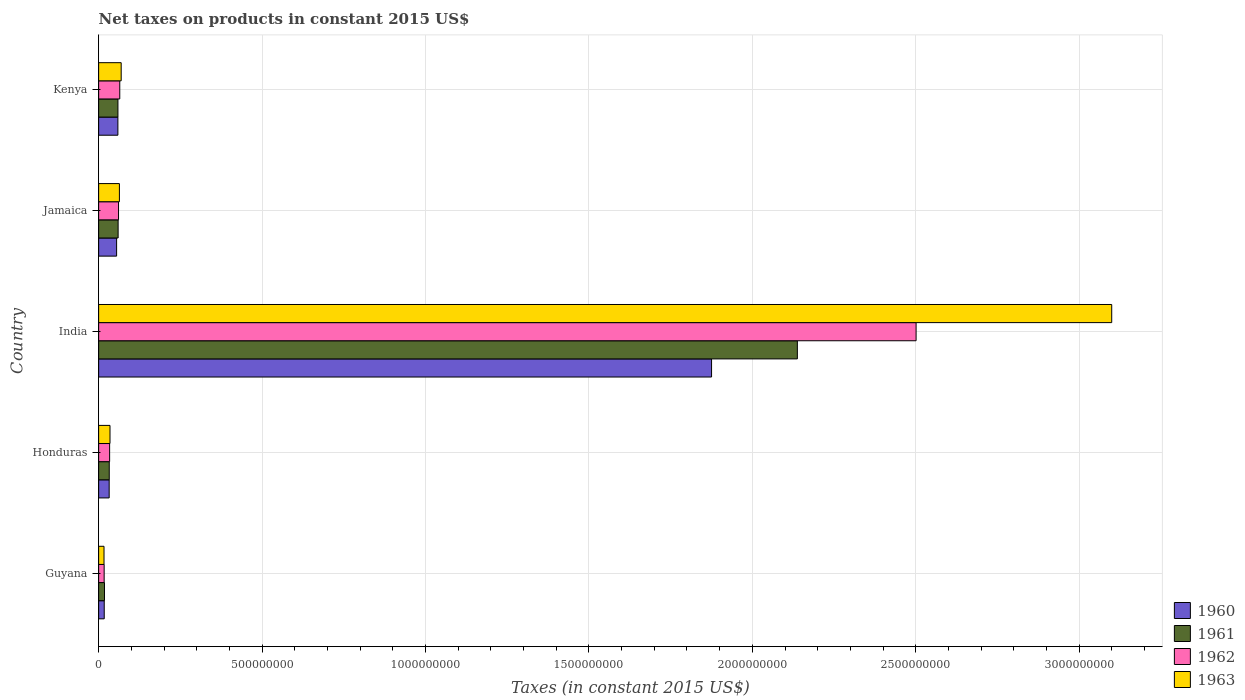How many different coloured bars are there?
Make the answer very short. 4. How many groups of bars are there?
Make the answer very short. 5. Are the number of bars on each tick of the Y-axis equal?
Offer a very short reply. Yes. How many bars are there on the 2nd tick from the top?
Provide a short and direct response. 4. How many bars are there on the 1st tick from the bottom?
Your response must be concise. 4. What is the label of the 2nd group of bars from the top?
Your answer should be very brief. Jamaica. In how many cases, is the number of bars for a given country not equal to the number of legend labels?
Offer a terse response. 0. What is the net taxes on products in 1962 in Guyana?
Your answer should be compact. 1.69e+07. Across all countries, what is the maximum net taxes on products in 1962?
Your answer should be very brief. 2.50e+09. Across all countries, what is the minimum net taxes on products in 1962?
Keep it short and to the point. 1.69e+07. In which country was the net taxes on products in 1960 minimum?
Ensure brevity in your answer.  Guyana. What is the total net taxes on products in 1961 in the graph?
Provide a succinct answer. 2.31e+09. What is the difference between the net taxes on products in 1961 in Guyana and that in Honduras?
Offer a very short reply. -1.46e+07. What is the difference between the net taxes on products in 1961 in Guyana and the net taxes on products in 1962 in Kenya?
Ensure brevity in your answer.  -4.67e+07. What is the average net taxes on products in 1963 per country?
Offer a terse response. 6.57e+08. What is the difference between the net taxes on products in 1962 and net taxes on products in 1960 in India?
Your answer should be compact. 6.26e+08. In how many countries, is the net taxes on products in 1963 greater than 2000000000 US$?
Provide a succinct answer. 1. What is the ratio of the net taxes on products in 1962 in Guyana to that in Honduras?
Give a very brief answer. 0.5. Is the net taxes on products in 1961 in Jamaica less than that in Kenya?
Provide a succinct answer. No. What is the difference between the highest and the second highest net taxes on products in 1960?
Ensure brevity in your answer.  1.82e+09. What is the difference between the highest and the lowest net taxes on products in 1960?
Give a very brief answer. 1.86e+09. In how many countries, is the net taxes on products in 1963 greater than the average net taxes on products in 1963 taken over all countries?
Offer a very short reply. 1. Is the sum of the net taxes on products in 1962 in Guyana and Honduras greater than the maximum net taxes on products in 1960 across all countries?
Offer a very short reply. No. Is it the case that in every country, the sum of the net taxes on products in 1962 and net taxes on products in 1963 is greater than the sum of net taxes on products in 1961 and net taxes on products in 1960?
Ensure brevity in your answer.  No. What does the 4th bar from the top in Honduras represents?
Your answer should be compact. 1960. What does the 4th bar from the bottom in Jamaica represents?
Provide a succinct answer. 1963. Is it the case that in every country, the sum of the net taxes on products in 1962 and net taxes on products in 1961 is greater than the net taxes on products in 1960?
Provide a short and direct response. Yes. How many bars are there?
Offer a very short reply. 20. How many countries are there in the graph?
Keep it short and to the point. 5. Are the values on the major ticks of X-axis written in scientific E-notation?
Offer a very short reply. No. Where does the legend appear in the graph?
Ensure brevity in your answer.  Bottom right. How many legend labels are there?
Make the answer very short. 4. How are the legend labels stacked?
Your answer should be very brief. Vertical. What is the title of the graph?
Make the answer very short. Net taxes on products in constant 2015 US$. What is the label or title of the X-axis?
Offer a very short reply. Taxes (in constant 2015 US$). What is the Taxes (in constant 2015 US$) of 1960 in Guyana?
Give a very brief answer. 1.71e+07. What is the Taxes (in constant 2015 US$) in 1961 in Guyana?
Your answer should be very brief. 1.79e+07. What is the Taxes (in constant 2015 US$) in 1962 in Guyana?
Offer a very short reply. 1.69e+07. What is the Taxes (in constant 2015 US$) of 1963 in Guyana?
Ensure brevity in your answer.  1.64e+07. What is the Taxes (in constant 2015 US$) in 1960 in Honduras?
Give a very brief answer. 3.22e+07. What is the Taxes (in constant 2015 US$) of 1961 in Honduras?
Provide a succinct answer. 3.25e+07. What is the Taxes (in constant 2015 US$) of 1962 in Honduras?
Ensure brevity in your answer.  3.36e+07. What is the Taxes (in constant 2015 US$) of 1963 in Honduras?
Provide a short and direct response. 3.48e+07. What is the Taxes (in constant 2015 US$) in 1960 in India?
Make the answer very short. 1.88e+09. What is the Taxes (in constant 2015 US$) of 1961 in India?
Offer a very short reply. 2.14e+09. What is the Taxes (in constant 2015 US$) of 1962 in India?
Offer a very short reply. 2.50e+09. What is the Taxes (in constant 2015 US$) in 1963 in India?
Provide a short and direct response. 3.10e+09. What is the Taxes (in constant 2015 US$) of 1960 in Jamaica?
Provide a succinct answer. 5.50e+07. What is the Taxes (in constant 2015 US$) of 1961 in Jamaica?
Make the answer very short. 5.96e+07. What is the Taxes (in constant 2015 US$) in 1962 in Jamaica?
Make the answer very short. 6.09e+07. What is the Taxes (in constant 2015 US$) in 1963 in Jamaica?
Your answer should be very brief. 6.36e+07. What is the Taxes (in constant 2015 US$) of 1960 in Kenya?
Your response must be concise. 5.89e+07. What is the Taxes (in constant 2015 US$) of 1961 in Kenya?
Make the answer very short. 5.91e+07. What is the Taxes (in constant 2015 US$) of 1962 in Kenya?
Your answer should be very brief. 6.47e+07. What is the Taxes (in constant 2015 US$) of 1963 in Kenya?
Your response must be concise. 6.90e+07. Across all countries, what is the maximum Taxes (in constant 2015 US$) in 1960?
Provide a succinct answer. 1.88e+09. Across all countries, what is the maximum Taxes (in constant 2015 US$) in 1961?
Provide a short and direct response. 2.14e+09. Across all countries, what is the maximum Taxes (in constant 2015 US$) of 1962?
Provide a short and direct response. 2.50e+09. Across all countries, what is the maximum Taxes (in constant 2015 US$) of 1963?
Your response must be concise. 3.10e+09. Across all countries, what is the minimum Taxes (in constant 2015 US$) in 1960?
Provide a short and direct response. 1.71e+07. Across all countries, what is the minimum Taxes (in constant 2015 US$) in 1961?
Your answer should be very brief. 1.79e+07. Across all countries, what is the minimum Taxes (in constant 2015 US$) in 1962?
Offer a very short reply. 1.69e+07. Across all countries, what is the minimum Taxes (in constant 2015 US$) in 1963?
Make the answer very short. 1.64e+07. What is the total Taxes (in constant 2015 US$) in 1960 in the graph?
Your response must be concise. 2.04e+09. What is the total Taxes (in constant 2015 US$) of 1961 in the graph?
Your answer should be compact. 2.31e+09. What is the total Taxes (in constant 2015 US$) in 1962 in the graph?
Keep it short and to the point. 2.68e+09. What is the total Taxes (in constant 2015 US$) of 1963 in the graph?
Your answer should be very brief. 3.28e+09. What is the difference between the Taxes (in constant 2015 US$) of 1960 in Guyana and that in Honduras?
Offer a very short reply. -1.51e+07. What is the difference between the Taxes (in constant 2015 US$) in 1961 in Guyana and that in Honduras?
Provide a short and direct response. -1.46e+07. What is the difference between the Taxes (in constant 2015 US$) of 1962 in Guyana and that in Honduras?
Keep it short and to the point. -1.67e+07. What is the difference between the Taxes (in constant 2015 US$) in 1963 in Guyana and that in Honduras?
Give a very brief answer. -1.84e+07. What is the difference between the Taxes (in constant 2015 US$) in 1960 in Guyana and that in India?
Give a very brief answer. -1.86e+09. What is the difference between the Taxes (in constant 2015 US$) of 1961 in Guyana and that in India?
Offer a very short reply. -2.12e+09. What is the difference between the Taxes (in constant 2015 US$) in 1962 in Guyana and that in India?
Your response must be concise. -2.48e+09. What is the difference between the Taxes (in constant 2015 US$) of 1963 in Guyana and that in India?
Offer a terse response. -3.08e+09. What is the difference between the Taxes (in constant 2015 US$) in 1960 in Guyana and that in Jamaica?
Your response must be concise. -3.79e+07. What is the difference between the Taxes (in constant 2015 US$) of 1961 in Guyana and that in Jamaica?
Your response must be concise. -4.17e+07. What is the difference between the Taxes (in constant 2015 US$) of 1962 in Guyana and that in Jamaica?
Offer a very short reply. -4.40e+07. What is the difference between the Taxes (in constant 2015 US$) in 1963 in Guyana and that in Jamaica?
Ensure brevity in your answer.  -4.71e+07. What is the difference between the Taxes (in constant 2015 US$) of 1960 in Guyana and that in Kenya?
Keep it short and to the point. -4.18e+07. What is the difference between the Taxes (in constant 2015 US$) of 1961 in Guyana and that in Kenya?
Offer a terse response. -4.12e+07. What is the difference between the Taxes (in constant 2015 US$) in 1962 in Guyana and that in Kenya?
Keep it short and to the point. -4.77e+07. What is the difference between the Taxes (in constant 2015 US$) in 1963 in Guyana and that in Kenya?
Give a very brief answer. -5.26e+07. What is the difference between the Taxes (in constant 2015 US$) of 1960 in Honduras and that in India?
Keep it short and to the point. -1.84e+09. What is the difference between the Taxes (in constant 2015 US$) of 1961 in Honduras and that in India?
Your answer should be compact. -2.11e+09. What is the difference between the Taxes (in constant 2015 US$) in 1962 in Honduras and that in India?
Give a very brief answer. -2.47e+09. What is the difference between the Taxes (in constant 2015 US$) in 1963 in Honduras and that in India?
Your response must be concise. -3.06e+09. What is the difference between the Taxes (in constant 2015 US$) in 1960 in Honduras and that in Jamaica?
Your answer should be compact. -2.28e+07. What is the difference between the Taxes (in constant 2015 US$) in 1961 in Honduras and that in Jamaica?
Provide a succinct answer. -2.71e+07. What is the difference between the Taxes (in constant 2015 US$) in 1962 in Honduras and that in Jamaica?
Offer a very short reply. -2.72e+07. What is the difference between the Taxes (in constant 2015 US$) of 1963 in Honduras and that in Jamaica?
Your answer should be very brief. -2.88e+07. What is the difference between the Taxes (in constant 2015 US$) of 1960 in Honduras and that in Kenya?
Give a very brief answer. -2.67e+07. What is the difference between the Taxes (in constant 2015 US$) of 1961 in Honduras and that in Kenya?
Offer a very short reply. -2.66e+07. What is the difference between the Taxes (in constant 2015 US$) of 1962 in Honduras and that in Kenya?
Keep it short and to the point. -3.10e+07. What is the difference between the Taxes (in constant 2015 US$) of 1963 in Honduras and that in Kenya?
Ensure brevity in your answer.  -3.42e+07. What is the difference between the Taxes (in constant 2015 US$) of 1960 in India and that in Jamaica?
Your answer should be very brief. 1.82e+09. What is the difference between the Taxes (in constant 2015 US$) in 1961 in India and that in Jamaica?
Offer a terse response. 2.08e+09. What is the difference between the Taxes (in constant 2015 US$) of 1962 in India and that in Jamaica?
Your answer should be very brief. 2.44e+09. What is the difference between the Taxes (in constant 2015 US$) of 1963 in India and that in Jamaica?
Provide a short and direct response. 3.04e+09. What is the difference between the Taxes (in constant 2015 US$) in 1960 in India and that in Kenya?
Keep it short and to the point. 1.82e+09. What is the difference between the Taxes (in constant 2015 US$) in 1961 in India and that in Kenya?
Give a very brief answer. 2.08e+09. What is the difference between the Taxes (in constant 2015 US$) of 1962 in India and that in Kenya?
Your answer should be very brief. 2.44e+09. What is the difference between the Taxes (in constant 2015 US$) in 1963 in India and that in Kenya?
Your answer should be very brief. 3.03e+09. What is the difference between the Taxes (in constant 2015 US$) in 1960 in Jamaica and that in Kenya?
Your answer should be compact. -3.91e+06. What is the difference between the Taxes (in constant 2015 US$) in 1961 in Jamaica and that in Kenya?
Provide a succinct answer. 5.74e+05. What is the difference between the Taxes (in constant 2015 US$) in 1962 in Jamaica and that in Kenya?
Provide a short and direct response. -3.75e+06. What is the difference between the Taxes (in constant 2015 US$) in 1963 in Jamaica and that in Kenya?
Ensure brevity in your answer.  -5.46e+06. What is the difference between the Taxes (in constant 2015 US$) in 1960 in Guyana and the Taxes (in constant 2015 US$) in 1961 in Honduras?
Ensure brevity in your answer.  -1.54e+07. What is the difference between the Taxes (in constant 2015 US$) in 1960 in Guyana and the Taxes (in constant 2015 US$) in 1962 in Honduras?
Offer a terse response. -1.65e+07. What is the difference between the Taxes (in constant 2015 US$) in 1960 in Guyana and the Taxes (in constant 2015 US$) in 1963 in Honduras?
Ensure brevity in your answer.  -1.77e+07. What is the difference between the Taxes (in constant 2015 US$) of 1961 in Guyana and the Taxes (in constant 2015 US$) of 1962 in Honduras?
Make the answer very short. -1.57e+07. What is the difference between the Taxes (in constant 2015 US$) of 1961 in Guyana and the Taxes (in constant 2015 US$) of 1963 in Honduras?
Your response must be concise. -1.69e+07. What is the difference between the Taxes (in constant 2015 US$) of 1962 in Guyana and the Taxes (in constant 2015 US$) of 1963 in Honduras?
Offer a terse response. -1.79e+07. What is the difference between the Taxes (in constant 2015 US$) in 1960 in Guyana and the Taxes (in constant 2015 US$) in 1961 in India?
Keep it short and to the point. -2.12e+09. What is the difference between the Taxes (in constant 2015 US$) in 1960 in Guyana and the Taxes (in constant 2015 US$) in 1962 in India?
Offer a terse response. -2.48e+09. What is the difference between the Taxes (in constant 2015 US$) of 1960 in Guyana and the Taxes (in constant 2015 US$) of 1963 in India?
Your answer should be compact. -3.08e+09. What is the difference between the Taxes (in constant 2015 US$) in 1961 in Guyana and the Taxes (in constant 2015 US$) in 1962 in India?
Your answer should be compact. -2.48e+09. What is the difference between the Taxes (in constant 2015 US$) of 1961 in Guyana and the Taxes (in constant 2015 US$) of 1963 in India?
Keep it short and to the point. -3.08e+09. What is the difference between the Taxes (in constant 2015 US$) of 1962 in Guyana and the Taxes (in constant 2015 US$) of 1963 in India?
Make the answer very short. -3.08e+09. What is the difference between the Taxes (in constant 2015 US$) in 1960 in Guyana and the Taxes (in constant 2015 US$) in 1961 in Jamaica?
Give a very brief answer. -4.25e+07. What is the difference between the Taxes (in constant 2015 US$) in 1960 in Guyana and the Taxes (in constant 2015 US$) in 1962 in Jamaica?
Provide a short and direct response. -4.38e+07. What is the difference between the Taxes (in constant 2015 US$) of 1960 in Guyana and the Taxes (in constant 2015 US$) of 1963 in Jamaica?
Your response must be concise. -4.64e+07. What is the difference between the Taxes (in constant 2015 US$) of 1961 in Guyana and the Taxes (in constant 2015 US$) of 1962 in Jamaica?
Your response must be concise. -4.30e+07. What is the difference between the Taxes (in constant 2015 US$) of 1961 in Guyana and the Taxes (in constant 2015 US$) of 1963 in Jamaica?
Keep it short and to the point. -4.57e+07. What is the difference between the Taxes (in constant 2015 US$) of 1962 in Guyana and the Taxes (in constant 2015 US$) of 1963 in Jamaica?
Give a very brief answer. -4.66e+07. What is the difference between the Taxes (in constant 2015 US$) in 1960 in Guyana and the Taxes (in constant 2015 US$) in 1961 in Kenya?
Ensure brevity in your answer.  -4.19e+07. What is the difference between the Taxes (in constant 2015 US$) in 1960 in Guyana and the Taxes (in constant 2015 US$) in 1962 in Kenya?
Keep it short and to the point. -4.75e+07. What is the difference between the Taxes (in constant 2015 US$) in 1960 in Guyana and the Taxes (in constant 2015 US$) in 1963 in Kenya?
Your answer should be very brief. -5.19e+07. What is the difference between the Taxes (in constant 2015 US$) in 1961 in Guyana and the Taxes (in constant 2015 US$) in 1962 in Kenya?
Provide a succinct answer. -4.67e+07. What is the difference between the Taxes (in constant 2015 US$) in 1961 in Guyana and the Taxes (in constant 2015 US$) in 1963 in Kenya?
Provide a short and direct response. -5.11e+07. What is the difference between the Taxes (in constant 2015 US$) in 1962 in Guyana and the Taxes (in constant 2015 US$) in 1963 in Kenya?
Ensure brevity in your answer.  -5.21e+07. What is the difference between the Taxes (in constant 2015 US$) of 1960 in Honduras and the Taxes (in constant 2015 US$) of 1961 in India?
Your answer should be compact. -2.11e+09. What is the difference between the Taxes (in constant 2015 US$) of 1960 in Honduras and the Taxes (in constant 2015 US$) of 1962 in India?
Keep it short and to the point. -2.47e+09. What is the difference between the Taxes (in constant 2015 US$) in 1960 in Honduras and the Taxes (in constant 2015 US$) in 1963 in India?
Offer a terse response. -3.07e+09. What is the difference between the Taxes (in constant 2015 US$) of 1961 in Honduras and the Taxes (in constant 2015 US$) of 1962 in India?
Your answer should be compact. -2.47e+09. What is the difference between the Taxes (in constant 2015 US$) in 1961 in Honduras and the Taxes (in constant 2015 US$) in 1963 in India?
Ensure brevity in your answer.  -3.07e+09. What is the difference between the Taxes (in constant 2015 US$) of 1962 in Honduras and the Taxes (in constant 2015 US$) of 1963 in India?
Keep it short and to the point. -3.07e+09. What is the difference between the Taxes (in constant 2015 US$) of 1960 in Honduras and the Taxes (in constant 2015 US$) of 1961 in Jamaica?
Offer a very short reply. -2.74e+07. What is the difference between the Taxes (in constant 2015 US$) of 1960 in Honduras and the Taxes (in constant 2015 US$) of 1962 in Jamaica?
Your response must be concise. -2.86e+07. What is the difference between the Taxes (in constant 2015 US$) of 1960 in Honduras and the Taxes (in constant 2015 US$) of 1963 in Jamaica?
Your answer should be very brief. -3.13e+07. What is the difference between the Taxes (in constant 2015 US$) of 1961 in Honduras and the Taxes (in constant 2015 US$) of 1962 in Jamaica?
Offer a very short reply. -2.84e+07. What is the difference between the Taxes (in constant 2015 US$) of 1961 in Honduras and the Taxes (in constant 2015 US$) of 1963 in Jamaica?
Provide a succinct answer. -3.11e+07. What is the difference between the Taxes (in constant 2015 US$) of 1962 in Honduras and the Taxes (in constant 2015 US$) of 1963 in Jamaica?
Provide a succinct answer. -2.99e+07. What is the difference between the Taxes (in constant 2015 US$) in 1960 in Honduras and the Taxes (in constant 2015 US$) in 1961 in Kenya?
Give a very brief answer. -2.68e+07. What is the difference between the Taxes (in constant 2015 US$) in 1960 in Honduras and the Taxes (in constant 2015 US$) in 1962 in Kenya?
Provide a short and direct response. -3.24e+07. What is the difference between the Taxes (in constant 2015 US$) in 1960 in Honduras and the Taxes (in constant 2015 US$) in 1963 in Kenya?
Ensure brevity in your answer.  -3.68e+07. What is the difference between the Taxes (in constant 2015 US$) of 1961 in Honduras and the Taxes (in constant 2015 US$) of 1962 in Kenya?
Offer a very short reply. -3.22e+07. What is the difference between the Taxes (in constant 2015 US$) in 1961 in Honduras and the Taxes (in constant 2015 US$) in 1963 in Kenya?
Offer a terse response. -3.65e+07. What is the difference between the Taxes (in constant 2015 US$) in 1962 in Honduras and the Taxes (in constant 2015 US$) in 1963 in Kenya?
Keep it short and to the point. -3.54e+07. What is the difference between the Taxes (in constant 2015 US$) of 1960 in India and the Taxes (in constant 2015 US$) of 1961 in Jamaica?
Provide a short and direct response. 1.82e+09. What is the difference between the Taxes (in constant 2015 US$) of 1960 in India and the Taxes (in constant 2015 US$) of 1962 in Jamaica?
Ensure brevity in your answer.  1.81e+09. What is the difference between the Taxes (in constant 2015 US$) in 1960 in India and the Taxes (in constant 2015 US$) in 1963 in Jamaica?
Your answer should be compact. 1.81e+09. What is the difference between the Taxes (in constant 2015 US$) in 1961 in India and the Taxes (in constant 2015 US$) in 1962 in Jamaica?
Make the answer very short. 2.08e+09. What is the difference between the Taxes (in constant 2015 US$) of 1961 in India and the Taxes (in constant 2015 US$) of 1963 in Jamaica?
Your response must be concise. 2.07e+09. What is the difference between the Taxes (in constant 2015 US$) in 1962 in India and the Taxes (in constant 2015 US$) in 1963 in Jamaica?
Give a very brief answer. 2.44e+09. What is the difference between the Taxes (in constant 2015 US$) in 1960 in India and the Taxes (in constant 2015 US$) in 1961 in Kenya?
Your answer should be very brief. 1.82e+09. What is the difference between the Taxes (in constant 2015 US$) in 1960 in India and the Taxes (in constant 2015 US$) in 1962 in Kenya?
Ensure brevity in your answer.  1.81e+09. What is the difference between the Taxes (in constant 2015 US$) in 1960 in India and the Taxes (in constant 2015 US$) in 1963 in Kenya?
Offer a terse response. 1.81e+09. What is the difference between the Taxes (in constant 2015 US$) in 1961 in India and the Taxes (in constant 2015 US$) in 1962 in Kenya?
Provide a short and direct response. 2.07e+09. What is the difference between the Taxes (in constant 2015 US$) of 1961 in India and the Taxes (in constant 2015 US$) of 1963 in Kenya?
Provide a succinct answer. 2.07e+09. What is the difference between the Taxes (in constant 2015 US$) of 1962 in India and the Taxes (in constant 2015 US$) of 1963 in Kenya?
Your answer should be compact. 2.43e+09. What is the difference between the Taxes (in constant 2015 US$) in 1960 in Jamaica and the Taxes (in constant 2015 US$) in 1961 in Kenya?
Give a very brief answer. -4.05e+06. What is the difference between the Taxes (in constant 2015 US$) in 1960 in Jamaica and the Taxes (in constant 2015 US$) in 1962 in Kenya?
Provide a succinct answer. -9.63e+06. What is the difference between the Taxes (in constant 2015 US$) of 1960 in Jamaica and the Taxes (in constant 2015 US$) of 1963 in Kenya?
Make the answer very short. -1.40e+07. What is the difference between the Taxes (in constant 2015 US$) of 1961 in Jamaica and the Taxes (in constant 2015 US$) of 1962 in Kenya?
Your answer should be compact. -5.01e+06. What is the difference between the Taxes (in constant 2015 US$) in 1961 in Jamaica and the Taxes (in constant 2015 US$) in 1963 in Kenya?
Provide a short and direct response. -9.38e+06. What is the difference between the Taxes (in constant 2015 US$) in 1962 in Jamaica and the Taxes (in constant 2015 US$) in 1963 in Kenya?
Make the answer very short. -8.12e+06. What is the average Taxes (in constant 2015 US$) of 1960 per country?
Ensure brevity in your answer.  4.08e+08. What is the average Taxes (in constant 2015 US$) of 1961 per country?
Offer a very short reply. 4.61e+08. What is the average Taxes (in constant 2015 US$) in 1962 per country?
Ensure brevity in your answer.  5.35e+08. What is the average Taxes (in constant 2015 US$) of 1963 per country?
Your answer should be very brief. 6.57e+08. What is the difference between the Taxes (in constant 2015 US$) in 1960 and Taxes (in constant 2015 US$) in 1961 in Guyana?
Offer a terse response. -7.58e+05. What is the difference between the Taxes (in constant 2015 US$) of 1960 and Taxes (in constant 2015 US$) of 1962 in Guyana?
Your answer should be compact. 2.33e+05. What is the difference between the Taxes (in constant 2015 US$) in 1960 and Taxes (in constant 2015 US$) in 1963 in Guyana?
Provide a succinct answer. 7.00e+05. What is the difference between the Taxes (in constant 2015 US$) in 1961 and Taxes (in constant 2015 US$) in 1962 in Guyana?
Your answer should be compact. 9.92e+05. What is the difference between the Taxes (in constant 2015 US$) in 1961 and Taxes (in constant 2015 US$) in 1963 in Guyana?
Offer a very short reply. 1.46e+06. What is the difference between the Taxes (in constant 2015 US$) of 1962 and Taxes (in constant 2015 US$) of 1963 in Guyana?
Make the answer very short. 4.67e+05. What is the difference between the Taxes (in constant 2015 US$) of 1960 and Taxes (in constant 2015 US$) of 1961 in Honduras?
Ensure brevity in your answer.  -2.50e+05. What is the difference between the Taxes (in constant 2015 US$) in 1960 and Taxes (in constant 2015 US$) in 1962 in Honduras?
Give a very brief answer. -1.40e+06. What is the difference between the Taxes (in constant 2015 US$) of 1960 and Taxes (in constant 2015 US$) of 1963 in Honduras?
Offer a very short reply. -2.55e+06. What is the difference between the Taxes (in constant 2015 US$) of 1961 and Taxes (in constant 2015 US$) of 1962 in Honduras?
Your answer should be very brief. -1.15e+06. What is the difference between the Taxes (in constant 2015 US$) of 1961 and Taxes (in constant 2015 US$) of 1963 in Honduras?
Your answer should be very brief. -2.30e+06. What is the difference between the Taxes (in constant 2015 US$) of 1962 and Taxes (in constant 2015 US$) of 1963 in Honduras?
Ensure brevity in your answer.  -1.15e+06. What is the difference between the Taxes (in constant 2015 US$) of 1960 and Taxes (in constant 2015 US$) of 1961 in India?
Your answer should be very brief. -2.63e+08. What is the difference between the Taxes (in constant 2015 US$) of 1960 and Taxes (in constant 2015 US$) of 1962 in India?
Provide a short and direct response. -6.26e+08. What is the difference between the Taxes (in constant 2015 US$) in 1960 and Taxes (in constant 2015 US$) in 1963 in India?
Provide a succinct answer. -1.22e+09. What is the difference between the Taxes (in constant 2015 US$) of 1961 and Taxes (in constant 2015 US$) of 1962 in India?
Keep it short and to the point. -3.63e+08. What is the difference between the Taxes (in constant 2015 US$) of 1961 and Taxes (in constant 2015 US$) of 1963 in India?
Give a very brief answer. -9.62e+08. What is the difference between the Taxes (in constant 2015 US$) of 1962 and Taxes (in constant 2015 US$) of 1963 in India?
Keep it short and to the point. -5.99e+08. What is the difference between the Taxes (in constant 2015 US$) in 1960 and Taxes (in constant 2015 US$) in 1961 in Jamaica?
Offer a terse response. -4.62e+06. What is the difference between the Taxes (in constant 2015 US$) of 1960 and Taxes (in constant 2015 US$) of 1962 in Jamaica?
Provide a short and direct response. -5.88e+06. What is the difference between the Taxes (in constant 2015 US$) of 1960 and Taxes (in constant 2015 US$) of 1963 in Jamaica?
Your response must be concise. -8.54e+06. What is the difference between the Taxes (in constant 2015 US$) in 1961 and Taxes (in constant 2015 US$) in 1962 in Jamaica?
Offer a very short reply. -1.26e+06. What is the difference between the Taxes (in constant 2015 US$) in 1961 and Taxes (in constant 2015 US$) in 1963 in Jamaica?
Keep it short and to the point. -3.92e+06. What is the difference between the Taxes (in constant 2015 US$) of 1962 and Taxes (in constant 2015 US$) of 1963 in Jamaica?
Provide a succinct answer. -2.66e+06. What is the difference between the Taxes (in constant 2015 US$) of 1960 and Taxes (in constant 2015 US$) of 1961 in Kenya?
Provide a succinct answer. -1.40e+05. What is the difference between the Taxes (in constant 2015 US$) of 1960 and Taxes (in constant 2015 US$) of 1962 in Kenya?
Keep it short and to the point. -5.73e+06. What is the difference between the Taxes (in constant 2015 US$) of 1960 and Taxes (in constant 2015 US$) of 1963 in Kenya?
Make the answer very short. -1.01e+07. What is the difference between the Taxes (in constant 2015 US$) in 1961 and Taxes (in constant 2015 US$) in 1962 in Kenya?
Provide a short and direct response. -5.59e+06. What is the difference between the Taxes (in constant 2015 US$) in 1961 and Taxes (in constant 2015 US$) in 1963 in Kenya?
Ensure brevity in your answer.  -9.95e+06. What is the difference between the Taxes (in constant 2015 US$) in 1962 and Taxes (in constant 2015 US$) in 1963 in Kenya?
Offer a very short reply. -4.37e+06. What is the ratio of the Taxes (in constant 2015 US$) of 1960 in Guyana to that in Honduras?
Offer a very short reply. 0.53. What is the ratio of the Taxes (in constant 2015 US$) in 1961 in Guyana to that in Honduras?
Give a very brief answer. 0.55. What is the ratio of the Taxes (in constant 2015 US$) in 1962 in Guyana to that in Honduras?
Keep it short and to the point. 0.5. What is the ratio of the Taxes (in constant 2015 US$) of 1963 in Guyana to that in Honduras?
Offer a very short reply. 0.47. What is the ratio of the Taxes (in constant 2015 US$) in 1960 in Guyana to that in India?
Your response must be concise. 0.01. What is the ratio of the Taxes (in constant 2015 US$) in 1961 in Guyana to that in India?
Keep it short and to the point. 0.01. What is the ratio of the Taxes (in constant 2015 US$) of 1962 in Guyana to that in India?
Provide a short and direct response. 0.01. What is the ratio of the Taxes (in constant 2015 US$) of 1963 in Guyana to that in India?
Provide a succinct answer. 0.01. What is the ratio of the Taxes (in constant 2015 US$) of 1960 in Guyana to that in Jamaica?
Your answer should be compact. 0.31. What is the ratio of the Taxes (in constant 2015 US$) in 1961 in Guyana to that in Jamaica?
Keep it short and to the point. 0.3. What is the ratio of the Taxes (in constant 2015 US$) in 1962 in Guyana to that in Jamaica?
Offer a terse response. 0.28. What is the ratio of the Taxes (in constant 2015 US$) in 1963 in Guyana to that in Jamaica?
Your answer should be very brief. 0.26. What is the ratio of the Taxes (in constant 2015 US$) in 1960 in Guyana to that in Kenya?
Your response must be concise. 0.29. What is the ratio of the Taxes (in constant 2015 US$) in 1961 in Guyana to that in Kenya?
Provide a succinct answer. 0.3. What is the ratio of the Taxes (in constant 2015 US$) of 1962 in Guyana to that in Kenya?
Offer a very short reply. 0.26. What is the ratio of the Taxes (in constant 2015 US$) of 1963 in Guyana to that in Kenya?
Your answer should be compact. 0.24. What is the ratio of the Taxes (in constant 2015 US$) of 1960 in Honduras to that in India?
Provide a succinct answer. 0.02. What is the ratio of the Taxes (in constant 2015 US$) of 1961 in Honduras to that in India?
Ensure brevity in your answer.  0.02. What is the ratio of the Taxes (in constant 2015 US$) of 1962 in Honduras to that in India?
Give a very brief answer. 0.01. What is the ratio of the Taxes (in constant 2015 US$) of 1963 in Honduras to that in India?
Ensure brevity in your answer.  0.01. What is the ratio of the Taxes (in constant 2015 US$) of 1960 in Honduras to that in Jamaica?
Make the answer very short. 0.59. What is the ratio of the Taxes (in constant 2015 US$) of 1961 in Honduras to that in Jamaica?
Provide a succinct answer. 0.54. What is the ratio of the Taxes (in constant 2015 US$) in 1962 in Honduras to that in Jamaica?
Give a very brief answer. 0.55. What is the ratio of the Taxes (in constant 2015 US$) in 1963 in Honduras to that in Jamaica?
Provide a short and direct response. 0.55. What is the ratio of the Taxes (in constant 2015 US$) of 1960 in Honduras to that in Kenya?
Provide a succinct answer. 0.55. What is the ratio of the Taxes (in constant 2015 US$) of 1961 in Honduras to that in Kenya?
Offer a terse response. 0.55. What is the ratio of the Taxes (in constant 2015 US$) of 1962 in Honduras to that in Kenya?
Your answer should be very brief. 0.52. What is the ratio of the Taxes (in constant 2015 US$) of 1963 in Honduras to that in Kenya?
Keep it short and to the point. 0.5. What is the ratio of the Taxes (in constant 2015 US$) in 1960 in India to that in Jamaica?
Your response must be concise. 34.08. What is the ratio of the Taxes (in constant 2015 US$) of 1961 in India to that in Jamaica?
Your answer should be compact. 35.85. What is the ratio of the Taxes (in constant 2015 US$) in 1962 in India to that in Jamaica?
Provide a short and direct response. 41.07. What is the ratio of the Taxes (in constant 2015 US$) of 1963 in India to that in Jamaica?
Keep it short and to the point. 48.77. What is the ratio of the Taxes (in constant 2015 US$) in 1960 in India to that in Kenya?
Keep it short and to the point. 31.82. What is the ratio of the Taxes (in constant 2015 US$) of 1961 in India to that in Kenya?
Your response must be concise. 36.19. What is the ratio of the Taxes (in constant 2015 US$) in 1962 in India to that in Kenya?
Offer a very short reply. 38.69. What is the ratio of the Taxes (in constant 2015 US$) in 1963 in India to that in Kenya?
Your answer should be compact. 44.91. What is the ratio of the Taxes (in constant 2015 US$) of 1960 in Jamaica to that in Kenya?
Ensure brevity in your answer.  0.93. What is the ratio of the Taxes (in constant 2015 US$) of 1961 in Jamaica to that in Kenya?
Offer a very short reply. 1.01. What is the ratio of the Taxes (in constant 2015 US$) of 1962 in Jamaica to that in Kenya?
Offer a very short reply. 0.94. What is the ratio of the Taxes (in constant 2015 US$) of 1963 in Jamaica to that in Kenya?
Give a very brief answer. 0.92. What is the difference between the highest and the second highest Taxes (in constant 2015 US$) in 1960?
Keep it short and to the point. 1.82e+09. What is the difference between the highest and the second highest Taxes (in constant 2015 US$) of 1961?
Offer a terse response. 2.08e+09. What is the difference between the highest and the second highest Taxes (in constant 2015 US$) in 1962?
Make the answer very short. 2.44e+09. What is the difference between the highest and the second highest Taxes (in constant 2015 US$) in 1963?
Your response must be concise. 3.03e+09. What is the difference between the highest and the lowest Taxes (in constant 2015 US$) in 1960?
Offer a very short reply. 1.86e+09. What is the difference between the highest and the lowest Taxes (in constant 2015 US$) in 1961?
Give a very brief answer. 2.12e+09. What is the difference between the highest and the lowest Taxes (in constant 2015 US$) of 1962?
Your response must be concise. 2.48e+09. What is the difference between the highest and the lowest Taxes (in constant 2015 US$) of 1963?
Make the answer very short. 3.08e+09. 